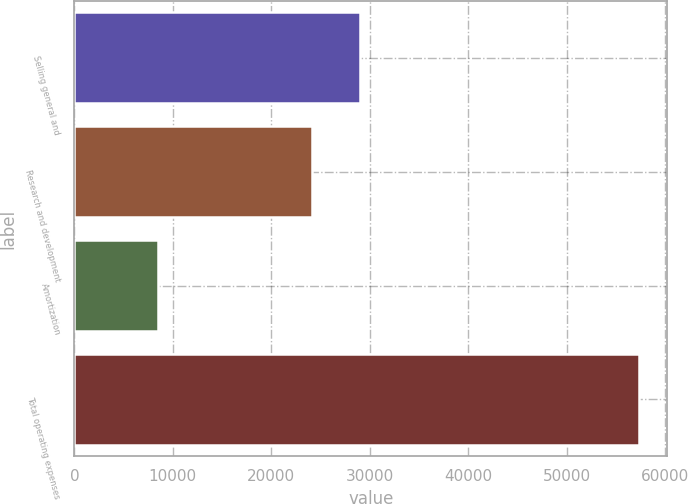Convert chart. <chart><loc_0><loc_0><loc_500><loc_500><bar_chart><fcel>Selling general and<fcel>Research and development<fcel>Amortization<fcel>Total operating expenses<nl><fcel>28989.9<fcel>24098<fcel>8454<fcel>57373<nl></chart> 